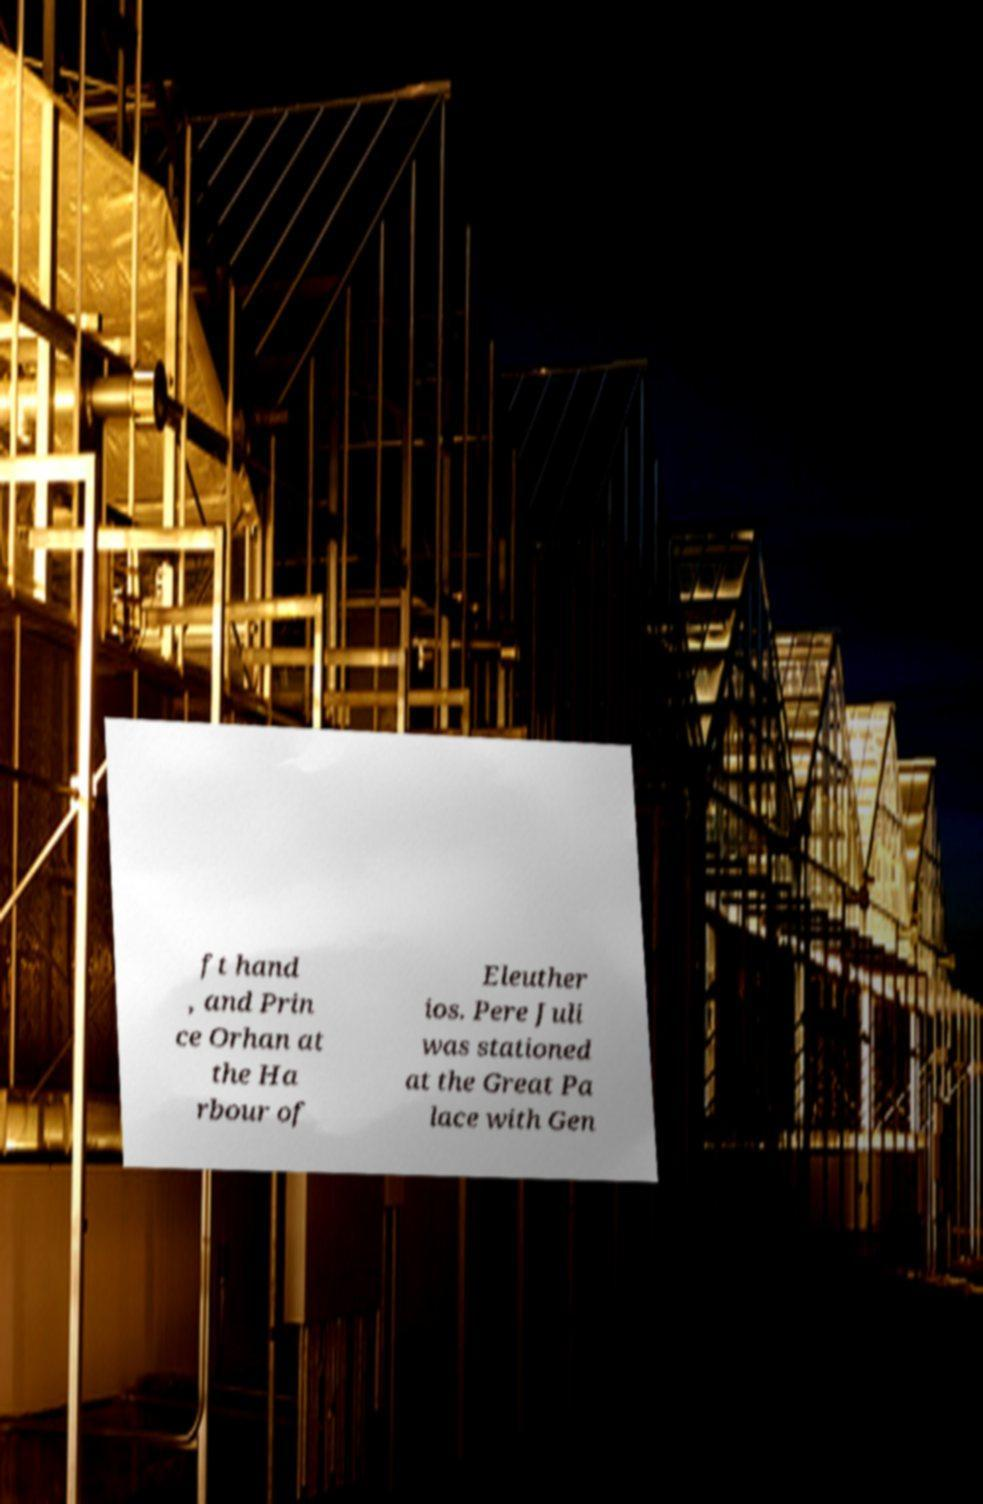What messages or text are displayed in this image? I need them in a readable, typed format. ft hand , and Prin ce Orhan at the Ha rbour of Eleuther ios. Pere Juli was stationed at the Great Pa lace with Gen 